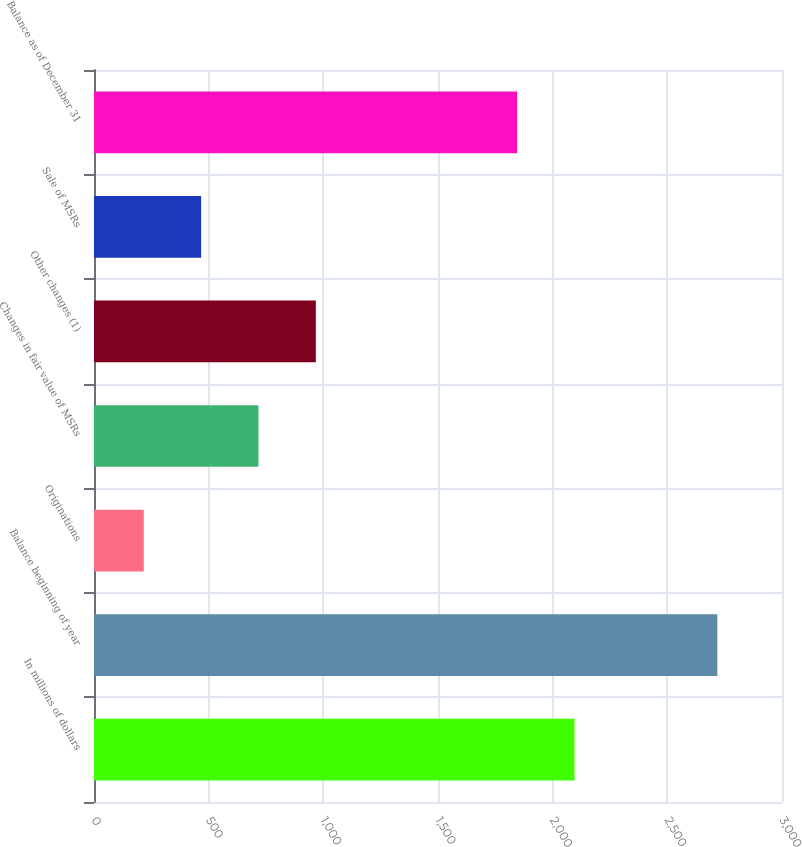Convert chart. <chart><loc_0><loc_0><loc_500><loc_500><bar_chart><fcel>In millions of dollars<fcel>Balance beginning of year<fcel>Originations<fcel>Changes in fair value of MSRs<fcel>Other changes (1)<fcel>Sale of MSRs<fcel>Balance as of December 31<nl><fcel>2095.1<fcel>2718<fcel>217<fcel>717.2<fcel>967.3<fcel>467.1<fcel>1845<nl></chart> 